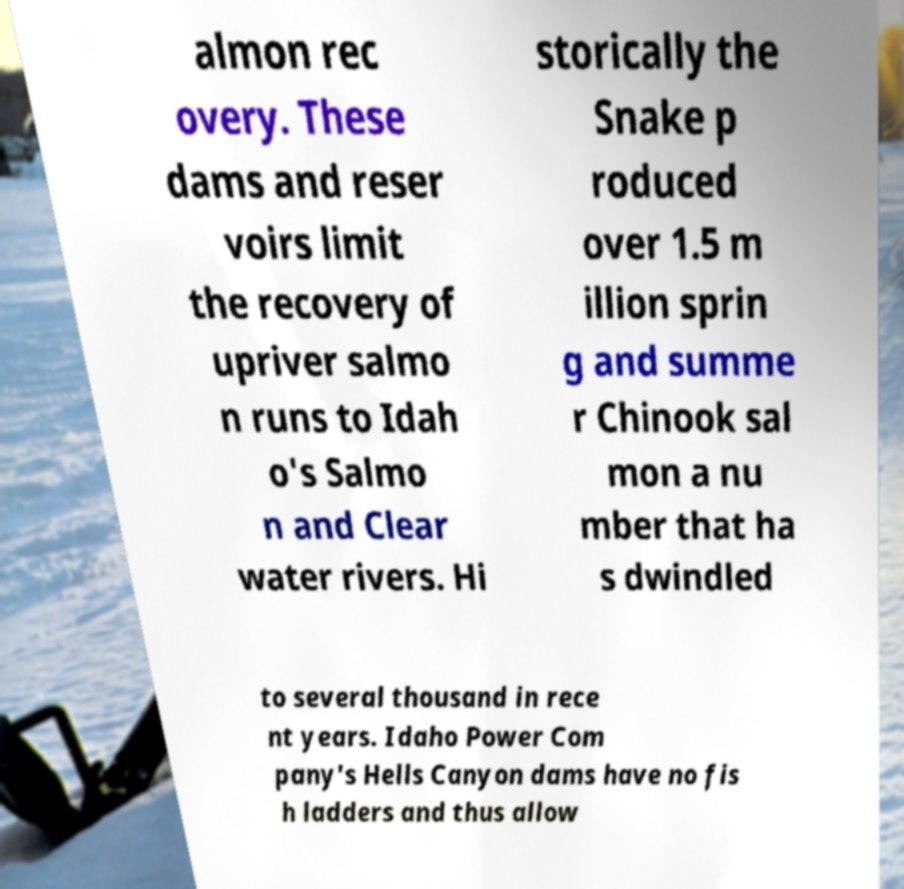What messages or text are displayed in this image? I need them in a readable, typed format. almon rec overy. These dams and reser voirs limit the recovery of upriver salmo n runs to Idah o's Salmo n and Clear water rivers. Hi storically the Snake p roduced over 1.5 m illion sprin g and summe r Chinook sal mon a nu mber that ha s dwindled to several thousand in rece nt years. Idaho Power Com pany's Hells Canyon dams have no fis h ladders and thus allow 